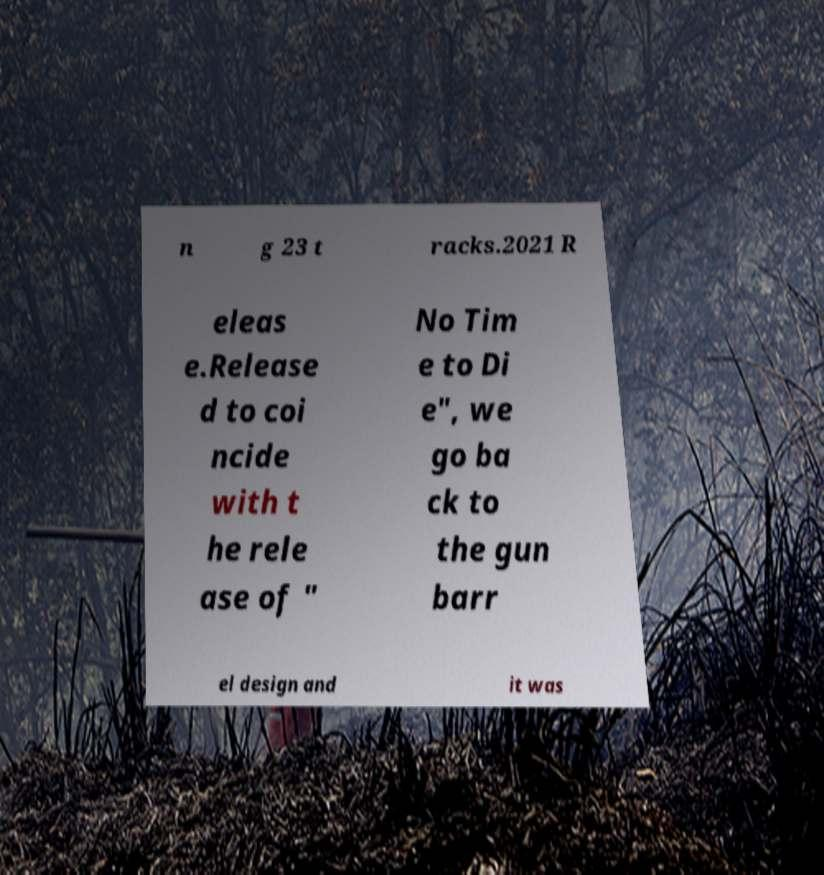What messages or text are displayed in this image? I need them in a readable, typed format. n g 23 t racks.2021 R eleas e.Release d to coi ncide with t he rele ase of " No Tim e to Di e", we go ba ck to the gun barr el design and it was 